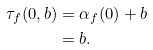Convert formula to latex. <formula><loc_0><loc_0><loc_500><loc_500>\tau _ { f } ( 0 , b ) & = \alpha _ { f } ( 0 ) + b \\ & = b .</formula> 